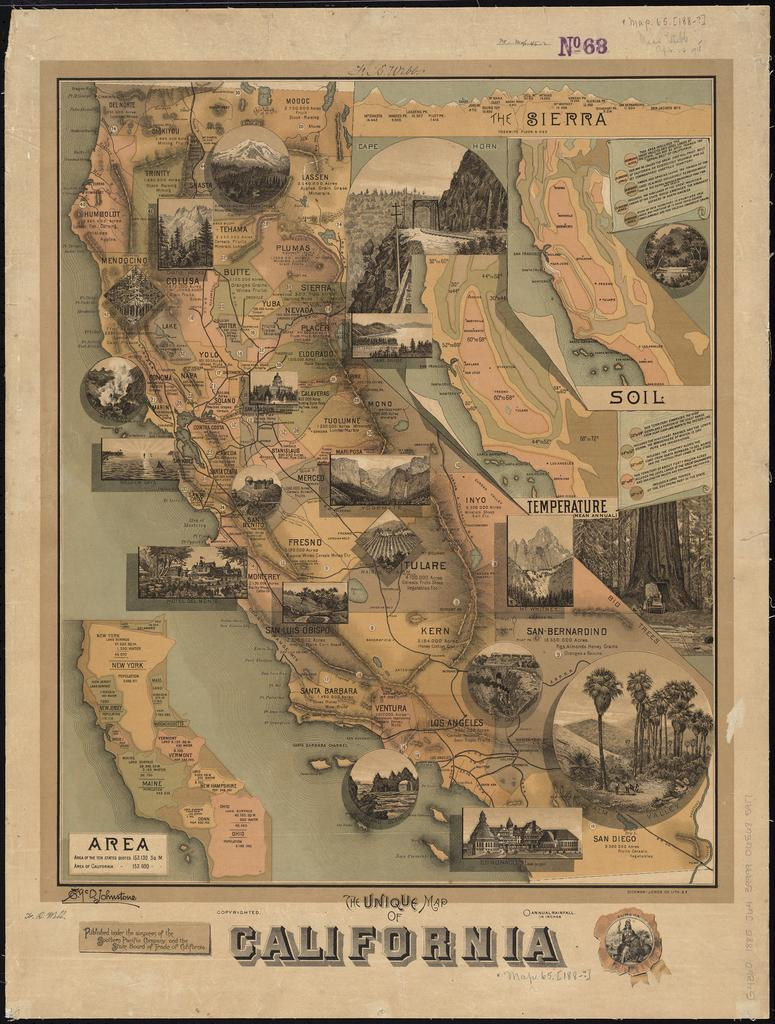<image>
Present a compact description of the photo's key features. a paper poster showing geographic areas in California 